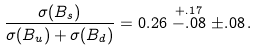<formula> <loc_0><loc_0><loc_500><loc_500>\frac { \sigma ( B _ { s } ) } { \sigma ( B _ { u } ) + \sigma ( B _ { d } ) } = 0 . 2 6 \stackrel { + . 1 7 } { - . 0 8 } \pm . 0 8 \, .</formula> 